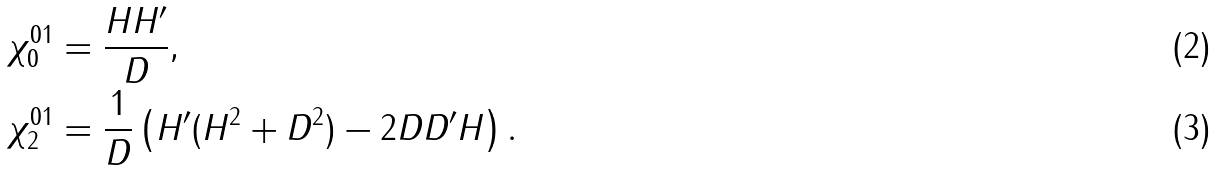<formula> <loc_0><loc_0><loc_500><loc_500>\chi ^ { 0 1 } _ { 0 } & = \frac { H H ^ { \prime } } { D } , \\ \chi ^ { 0 1 } _ { 2 } & = \frac { 1 } { D } \left ( H ^ { \prime } ( H ^ { 2 } + D ^ { 2 } ) - 2 D D ^ { \prime } H \right ) .</formula> 